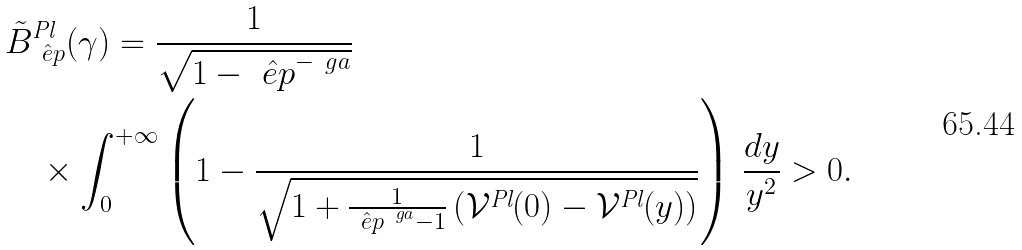Convert formula to latex. <formula><loc_0><loc_0><loc_500><loc_500>& \tilde { B } _ { \hat { \ e p } } ^ { \text {Pl} } ( \gamma ) = \frac { 1 } { \sqrt { 1 - \hat { \ e p } ^ { - \ g a } } } \\ & \quad \times \int _ { 0 } ^ { + \infty } \left ( 1 - \frac { 1 } { \sqrt { 1 + \frac { 1 } { \hat { \ e p } ^ { \ g a } - 1 } \left ( \mathcal { V } ^ { \text {Pl} } ( 0 ) - \mathcal { V } ^ { \text {Pl} } ( y ) \right ) } } \right ) \, \frac { d y } { y ^ { 2 } } > 0 .</formula> 